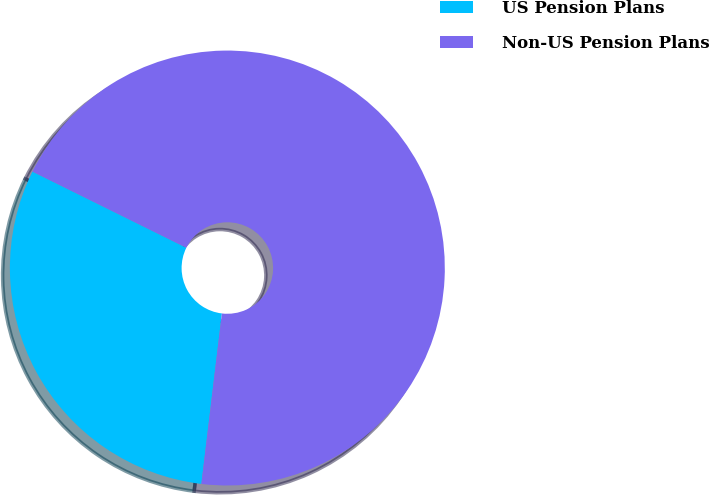Convert chart to OTSL. <chart><loc_0><loc_0><loc_500><loc_500><pie_chart><fcel>US Pension Plans<fcel>Non-US Pension Plans<nl><fcel>30.41%<fcel>69.59%<nl></chart> 